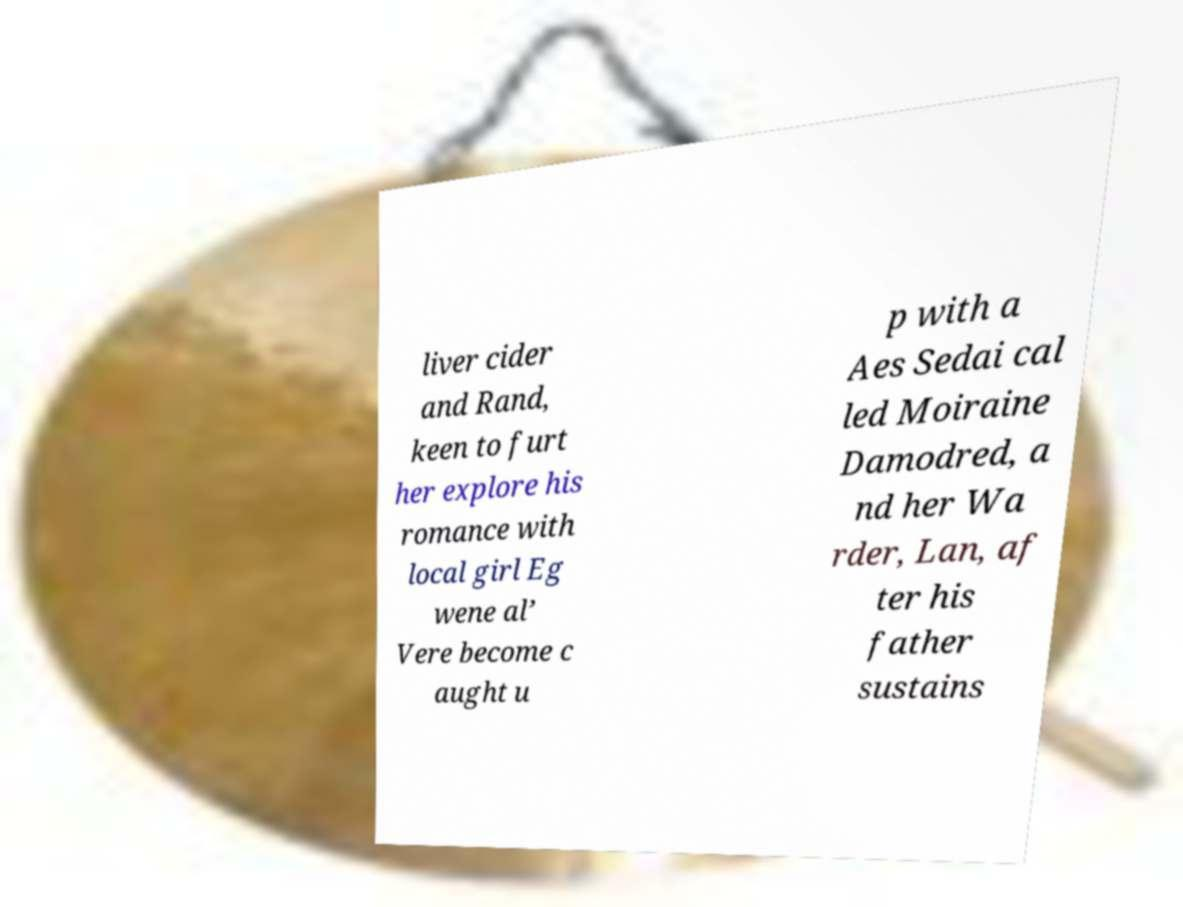Can you accurately transcribe the text from the provided image for me? liver cider and Rand, keen to furt her explore his romance with local girl Eg wene al’ Vere become c aught u p with a Aes Sedai cal led Moiraine Damodred, a nd her Wa rder, Lan, af ter his father sustains 